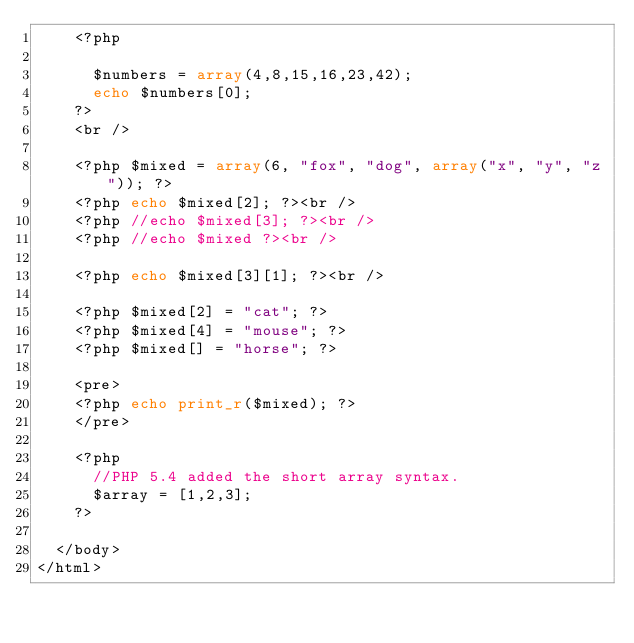<code> <loc_0><loc_0><loc_500><loc_500><_PHP_>    <?php
    
      $numbers = array(4,8,15,16,23,42);
      echo $numbers[0];
    ?>
    <br />
    
    <?php $mixed = array(6, "fox", "dog", array("x", "y", "z")); ?>
    <?php echo $mixed[2]; ?><br />
    <?php //echo $mixed[3]; ?><br />
    <?php //echo $mixed ?><br />
    
    <?php echo $mixed[3][1]; ?><br />
    
    <?php $mixed[2] = "cat"; ?>
    <?php $mixed[4] = "mouse"; ?>
    <?php $mixed[] = "horse"; ?>
    
    <pre>
    <?php echo print_r($mixed); ?>
    </pre>
    
    <?php 
      //PHP 5.4 added the short array syntax.
      $array = [1,2,3];
    ?>
    
  </body>
</html>
</code> 